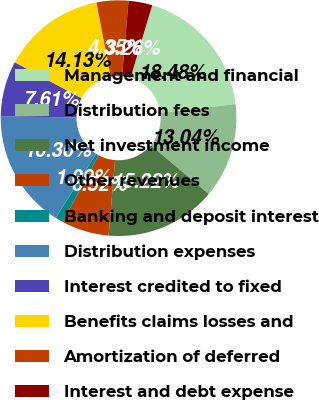Convert chart to OTSL. <chart><loc_0><loc_0><loc_500><loc_500><pie_chart><fcel>Management and financial<fcel>Distribution fees<fcel>Net investment income<fcel>Other revenues<fcel>Banking and deposit interest<fcel>Distribution expenses<fcel>Interest credited to fixed<fcel>Benefits claims losses and<fcel>Amortization of deferred<fcel>Interest and debt expense<nl><fcel>18.48%<fcel>13.04%<fcel>15.22%<fcel>6.52%<fcel>1.09%<fcel>16.3%<fcel>7.61%<fcel>14.13%<fcel>4.35%<fcel>3.26%<nl></chart> 